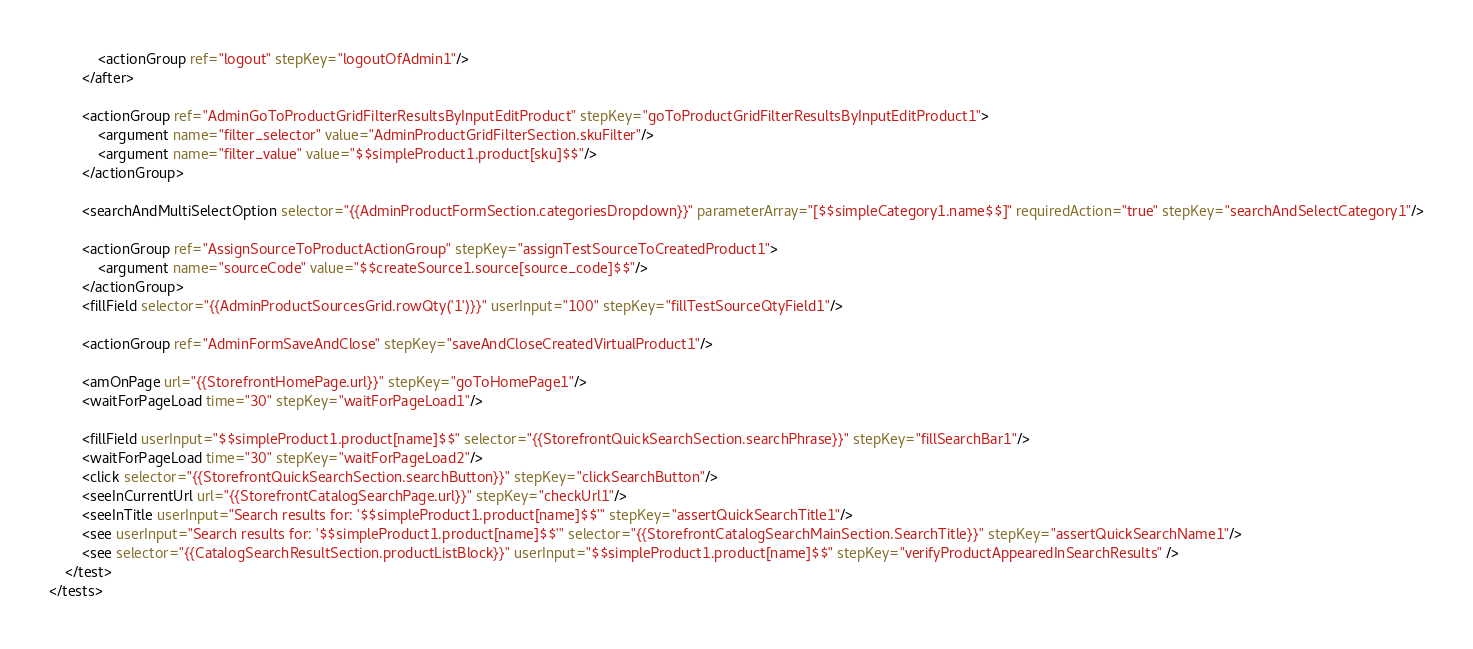<code> <loc_0><loc_0><loc_500><loc_500><_XML_>            <actionGroup ref="logout" stepKey="logoutOfAdmin1"/>
        </after>

        <actionGroup ref="AdminGoToProductGridFilterResultsByInputEditProduct" stepKey="goToProductGridFilterResultsByInputEditProduct1">
            <argument name="filter_selector" value="AdminProductGridFilterSection.skuFilter"/>
            <argument name="filter_value" value="$$simpleProduct1.product[sku]$$"/>
        </actionGroup>

        <searchAndMultiSelectOption selector="{{AdminProductFormSection.categoriesDropdown}}" parameterArray="[$$simpleCategory1.name$$]" requiredAction="true" stepKey="searchAndSelectCategory1"/>

        <actionGroup ref="AssignSourceToProductActionGroup" stepKey="assignTestSourceToCreatedProduct1">
            <argument name="sourceCode" value="$$createSource1.source[source_code]$$"/>
        </actionGroup>
        <fillField selector="{{AdminProductSourcesGrid.rowQty('1')}}" userInput="100" stepKey="fillTestSourceQtyField1"/>

        <actionGroup ref="AdminFormSaveAndClose" stepKey="saveAndCloseCreatedVirtualProduct1"/>

        <amOnPage url="{{StorefrontHomePage.url}}" stepKey="goToHomePage1"/>
        <waitForPageLoad time="30" stepKey="waitForPageLoad1"/>

        <fillField userInput="$$simpleProduct1.product[name]$$" selector="{{StorefrontQuickSearchSection.searchPhrase}}" stepKey="fillSearchBar1"/>
        <waitForPageLoad time="30" stepKey="waitForPageLoad2"/>
        <click selector="{{StorefrontQuickSearchSection.searchButton}}" stepKey="clickSearchButton"/>
        <seeInCurrentUrl url="{{StorefrontCatalogSearchPage.url}}" stepKey="checkUrl1"/>
        <seeInTitle userInput="Search results for: '$$simpleProduct1.product[name]$$'" stepKey="assertQuickSearchTitle1"/>
        <see userInput="Search results for: '$$simpleProduct1.product[name]$$'" selector="{{StorefrontCatalogSearchMainSection.SearchTitle}}" stepKey="assertQuickSearchName1"/>
        <see selector="{{CatalogSearchResultSection.productListBlock}}" userInput="$$simpleProduct1.product[name]$$" stepKey="verifyProductAppearedInSearchResults" />
    </test>
</tests>
</code> 